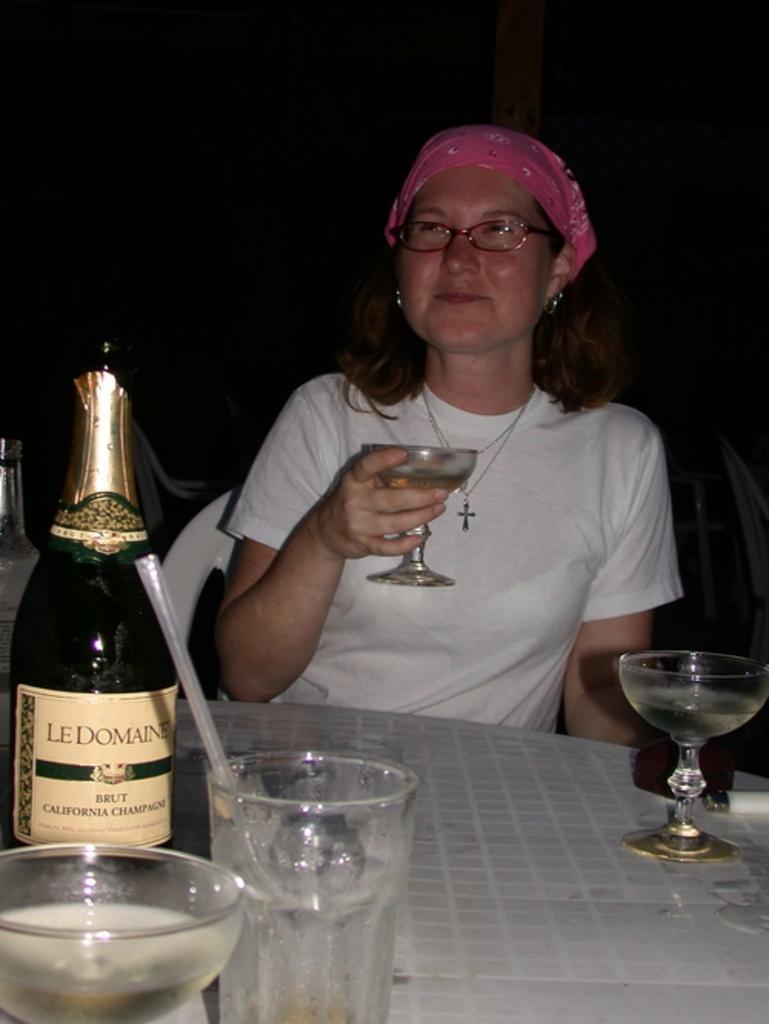In one or two sentences, can you explain what this image depicts? Background is dark. We can see a woman sitting on chair , wearing white shirt and spectacles. She is holding a wine glass in her hand and smiling. On the table we can see bottle, glasses and a lighter. 